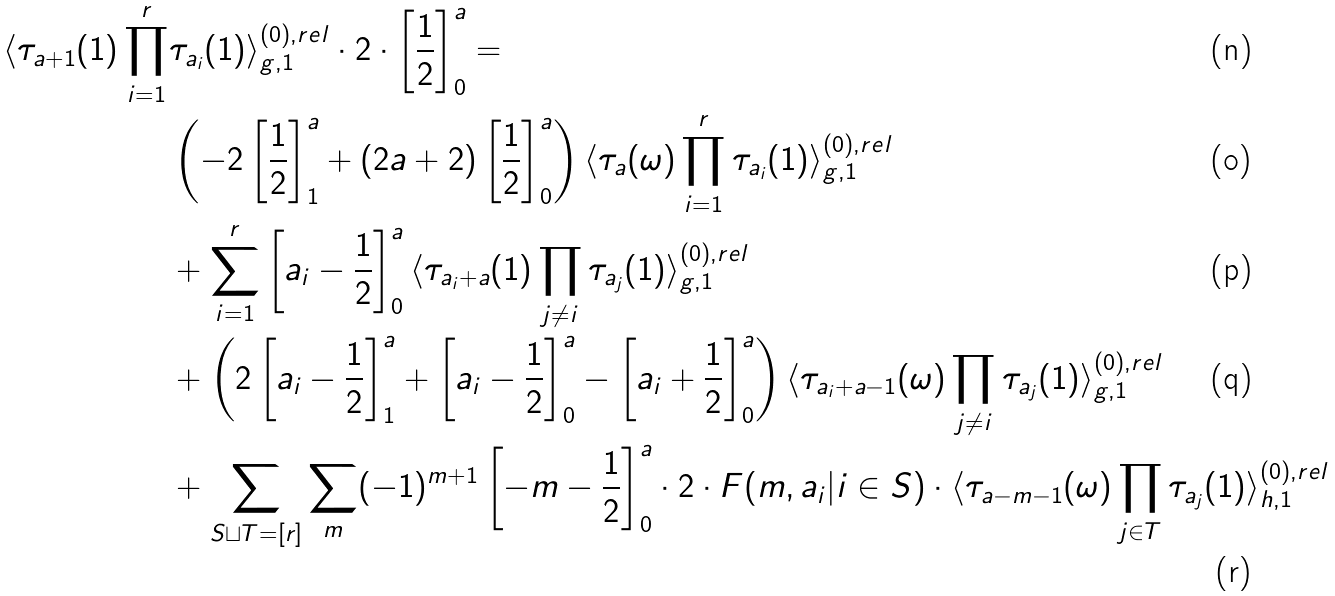Convert formula to latex. <formula><loc_0><loc_0><loc_500><loc_500>\langle \tau _ { a + 1 } ( 1 ) \prod _ { i = 1 } ^ { r } & \tau _ { a _ { i } } ( 1 ) \rangle ^ { ( 0 ) , r e l } _ { g , 1 } \cdot 2 \cdot \left [ \frac { 1 } { 2 } \right ] ^ { a } _ { 0 } = \\ & \left ( - 2 \left [ \frac { 1 } { 2 } \right ] ^ { a } _ { 1 } + ( 2 a + 2 ) \left [ \frac { 1 } { 2 } \right ] ^ { a } _ { 0 } \right ) \langle \tau _ { a } ( \omega ) \prod _ { i = 1 } ^ { r } \tau _ { a _ { i } } ( 1 ) \rangle ^ { ( 0 ) , r e l } _ { g , 1 } \\ & + \sum _ { i = 1 } ^ { r } \left [ a _ { i } - \frac { 1 } { 2 } \right ] ^ { a } _ { 0 } \langle \tau _ { a _ { i } + a } ( 1 ) \prod _ { j \neq i } \tau _ { a _ { j } } ( 1 ) \rangle ^ { ( 0 ) , r e l } _ { g , 1 } \\ & + \left ( 2 \left [ a _ { i } - \frac { 1 } { 2 } \right ] ^ { a } _ { 1 } + \left [ a _ { i } - \frac { 1 } { 2 } \right ] ^ { a } _ { 0 } - \left [ a _ { i } + \frac { 1 } { 2 } \right ] ^ { a } _ { 0 } \right ) \langle \tau _ { a _ { i } + a - 1 } ( \omega ) \prod _ { j \neq i } \tau _ { a _ { j } } ( 1 ) \rangle ^ { ( 0 ) , r e l } _ { g , 1 } \\ & + \sum _ { S \sqcup T = [ r ] } \sum _ { m } ( - 1 ) ^ { m + 1 } \left [ - m - \frac { 1 } { 2 } \right ] ^ { a } _ { 0 } \cdot 2 \cdot F ( m , a _ { i } | i \in S ) \cdot \langle \tau _ { a - m - 1 } ( \omega ) \prod _ { j \in T } \tau _ { a _ { j } } ( 1 ) \rangle ^ { ( 0 ) , r e l } _ { h , 1 }</formula> 